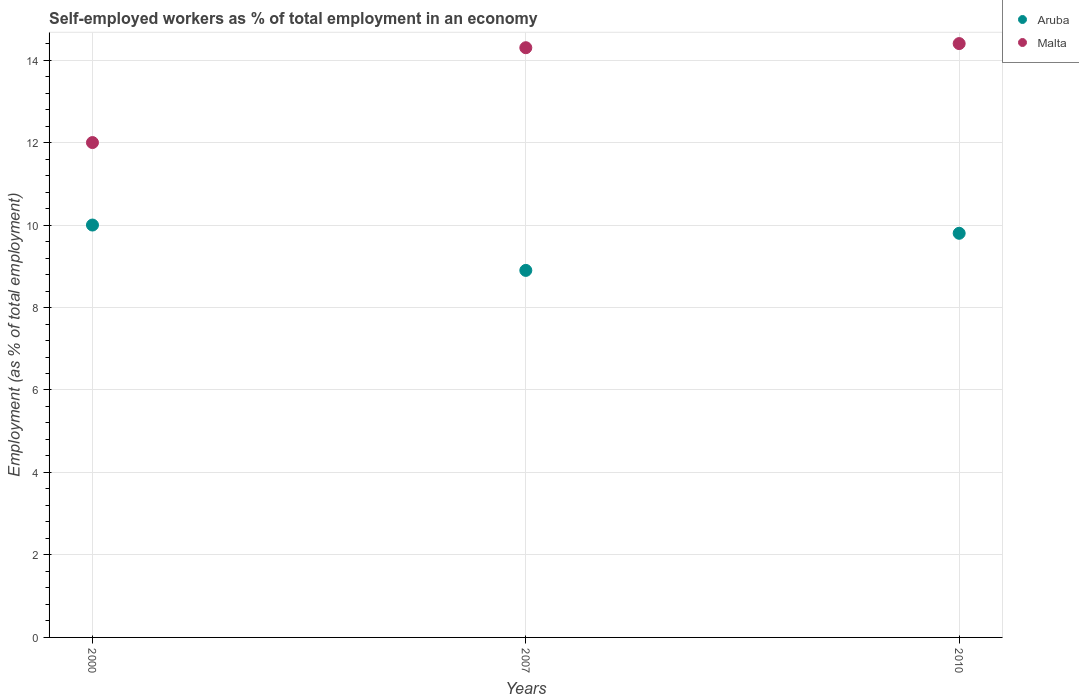What is the percentage of self-employed workers in Aruba in 2010?
Make the answer very short. 9.8. Across all years, what is the maximum percentage of self-employed workers in Malta?
Make the answer very short. 14.4. Across all years, what is the minimum percentage of self-employed workers in Malta?
Offer a very short reply. 12. In which year was the percentage of self-employed workers in Malta minimum?
Ensure brevity in your answer.  2000. What is the total percentage of self-employed workers in Aruba in the graph?
Keep it short and to the point. 28.7. What is the difference between the percentage of self-employed workers in Malta in 2007 and that in 2010?
Make the answer very short. -0.1. What is the difference between the percentage of self-employed workers in Aruba in 2007 and the percentage of self-employed workers in Malta in 2010?
Keep it short and to the point. -5.5. What is the average percentage of self-employed workers in Aruba per year?
Your response must be concise. 9.57. In the year 2010, what is the difference between the percentage of self-employed workers in Aruba and percentage of self-employed workers in Malta?
Make the answer very short. -4.6. What is the ratio of the percentage of self-employed workers in Malta in 2000 to that in 2007?
Offer a very short reply. 0.84. Is the difference between the percentage of self-employed workers in Aruba in 2007 and 2010 greater than the difference between the percentage of self-employed workers in Malta in 2007 and 2010?
Your answer should be very brief. No. What is the difference between the highest and the second highest percentage of self-employed workers in Aruba?
Make the answer very short. 0.2. What is the difference between the highest and the lowest percentage of self-employed workers in Malta?
Give a very brief answer. 2.4. In how many years, is the percentage of self-employed workers in Aruba greater than the average percentage of self-employed workers in Aruba taken over all years?
Give a very brief answer. 2. Is the percentage of self-employed workers in Malta strictly greater than the percentage of self-employed workers in Aruba over the years?
Your response must be concise. Yes. How many years are there in the graph?
Ensure brevity in your answer.  3. Does the graph contain any zero values?
Offer a very short reply. No. What is the title of the graph?
Provide a short and direct response. Self-employed workers as % of total employment in an economy. What is the label or title of the X-axis?
Your answer should be very brief. Years. What is the label or title of the Y-axis?
Give a very brief answer. Employment (as % of total employment). What is the Employment (as % of total employment) of Aruba in 2007?
Offer a terse response. 8.9. What is the Employment (as % of total employment) of Malta in 2007?
Give a very brief answer. 14.3. What is the Employment (as % of total employment) of Aruba in 2010?
Give a very brief answer. 9.8. What is the Employment (as % of total employment) in Malta in 2010?
Provide a succinct answer. 14.4. Across all years, what is the maximum Employment (as % of total employment) in Malta?
Keep it short and to the point. 14.4. Across all years, what is the minimum Employment (as % of total employment) of Aruba?
Ensure brevity in your answer.  8.9. Across all years, what is the minimum Employment (as % of total employment) in Malta?
Your answer should be compact. 12. What is the total Employment (as % of total employment) in Aruba in the graph?
Give a very brief answer. 28.7. What is the total Employment (as % of total employment) in Malta in the graph?
Ensure brevity in your answer.  40.7. What is the difference between the Employment (as % of total employment) in Aruba in 2000 and that in 2007?
Ensure brevity in your answer.  1.1. What is the difference between the Employment (as % of total employment) in Aruba in 2000 and the Employment (as % of total employment) in Malta in 2010?
Give a very brief answer. -4.4. What is the difference between the Employment (as % of total employment) of Aruba in 2007 and the Employment (as % of total employment) of Malta in 2010?
Your answer should be compact. -5.5. What is the average Employment (as % of total employment) of Aruba per year?
Ensure brevity in your answer.  9.57. What is the average Employment (as % of total employment) of Malta per year?
Provide a short and direct response. 13.57. In the year 2000, what is the difference between the Employment (as % of total employment) in Aruba and Employment (as % of total employment) in Malta?
Keep it short and to the point. -2. In the year 2007, what is the difference between the Employment (as % of total employment) of Aruba and Employment (as % of total employment) of Malta?
Your answer should be compact. -5.4. In the year 2010, what is the difference between the Employment (as % of total employment) of Aruba and Employment (as % of total employment) of Malta?
Your answer should be compact. -4.6. What is the ratio of the Employment (as % of total employment) of Aruba in 2000 to that in 2007?
Ensure brevity in your answer.  1.12. What is the ratio of the Employment (as % of total employment) of Malta in 2000 to that in 2007?
Offer a very short reply. 0.84. What is the ratio of the Employment (as % of total employment) of Aruba in 2000 to that in 2010?
Keep it short and to the point. 1.02. What is the ratio of the Employment (as % of total employment) in Aruba in 2007 to that in 2010?
Provide a short and direct response. 0.91. What is the difference between the highest and the second highest Employment (as % of total employment) of Aruba?
Your answer should be compact. 0.2. What is the difference between the highest and the second highest Employment (as % of total employment) of Malta?
Offer a very short reply. 0.1. 